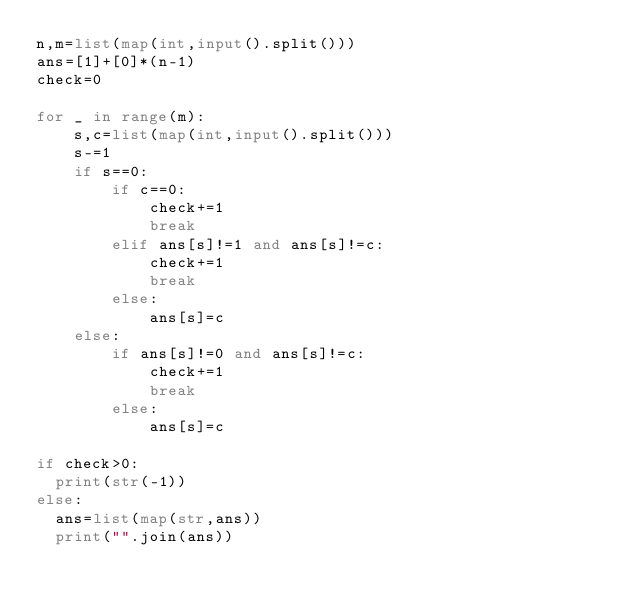Convert code to text. <code><loc_0><loc_0><loc_500><loc_500><_Python_>n,m=list(map(int,input().split()))
ans=[1]+[0]*(n-1)
check=0

for _ in range(m):
    s,c=list(map(int,input().split()))
    s-=1
    if s==0:
        if c==0:
            check+=1
            break
        elif ans[s]!=1 and ans[s]!=c:
            check+=1
            break
        else:
            ans[s]=c
    else:
        if ans[s]!=0 and ans[s]!=c:
            check+=1
            break
        else:
            ans[s]=c

if check>0:
  print(str(-1))
else:
  ans=list(map(str,ans))
  print("".join(ans))
</code> 